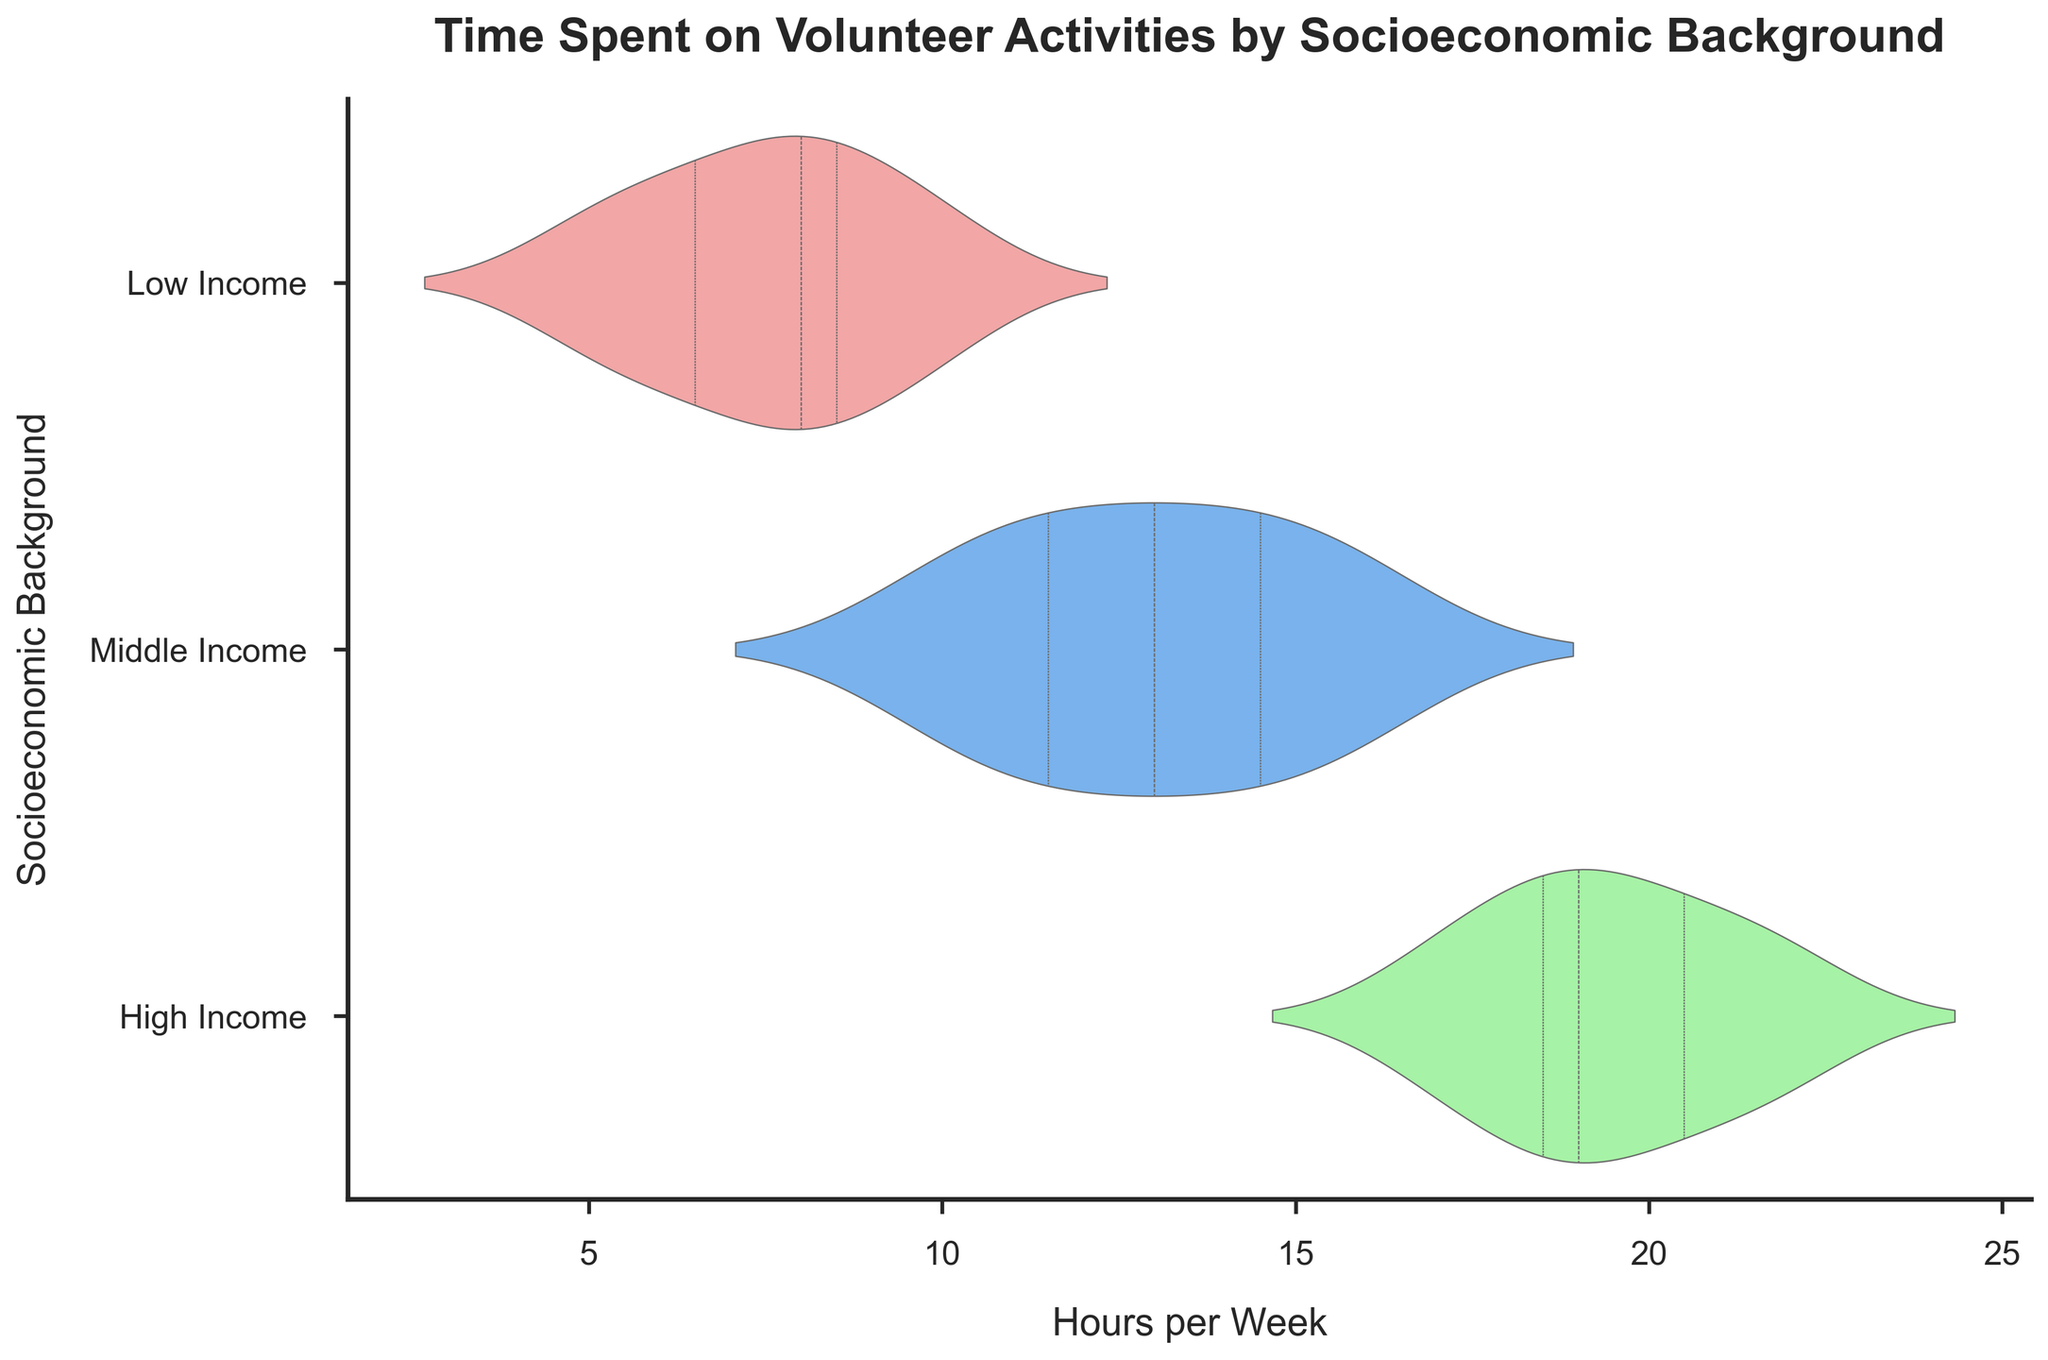What is the title of the chart? The title of the chart is displayed at the top and reads, "Time Spent on Volunteer Activities by Socioeconomic Background".
Answer: Time Spent on Volunteer Activities by Socioeconomic Background What is the average time spent on volunteer activities by college students from a middle-income background? To find the average time, identify the data points associated with middle-income backgrounds (10, 11, 12, 13, 14, 15, 16), then sum them: 10 + 11 + 12 + 13 + 14 + 15 + 16 = 91. The average is 91 divided by the number of data points (7), which is 91/7.
Answer: 13 Which socioeconomic background shows the highest range of time spent on volunteer activities? To determine the range, look at the spread of the violins. The high-income background shows the widest spread, indicating a range from about 17 to 22 hours per week.
Answer: High income Do college students from a low-income background spend more or less time volunteering compared to those from a high-income background? Compare the spread and central tendency of the violins for low-income and high-income backgrounds. Low-income students' time ranges roughly between 5 to 10 hours, while high-income students' time ranges between 17 to 22 hours.
Answer: Less What is the median time spent on volunteer activities by students from a high-income background? The median time is represented by the white dot within each violin. For the high-income background, this dot is approximately at 19 hours.
Answer: 19 hours How does the interquartile range (IQR) for middle-income students compare to that of low-income students? The IQR is represented by the thick black bar within each violin. For middle-income students, this bar spans from about 10 to 15 hours. For low-income students, it spans from about 6 to 9 hours.
Answer: Greater What are the axis labels in the chart? The x-axis is labeled "Hours per Week" and the y-axis is labeled "Socioeconomic Background". These labels are clearly displayed to provide context.
Answer: Hours per Week; Socioeconomic Background Which group has the smallest variation in time spent on volunteer activities? Variation can be observed by the width and spread of each violin plot. The low-income group shows the smallest spread, indicating the least variation.
Answer: Low income 